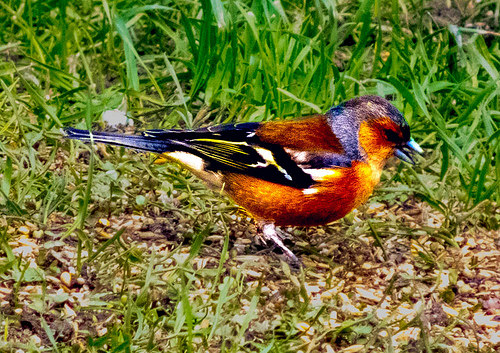<image>
Can you confirm if the bird is behind the grass? Yes. From this viewpoint, the bird is positioned behind the grass, with the grass partially or fully occluding the bird. 